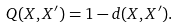<formula> <loc_0><loc_0><loc_500><loc_500>Q ( { X } , { X ^ { \prime } } ) = 1 - d ( { X } , { X ^ { \prime } } ) .</formula> 